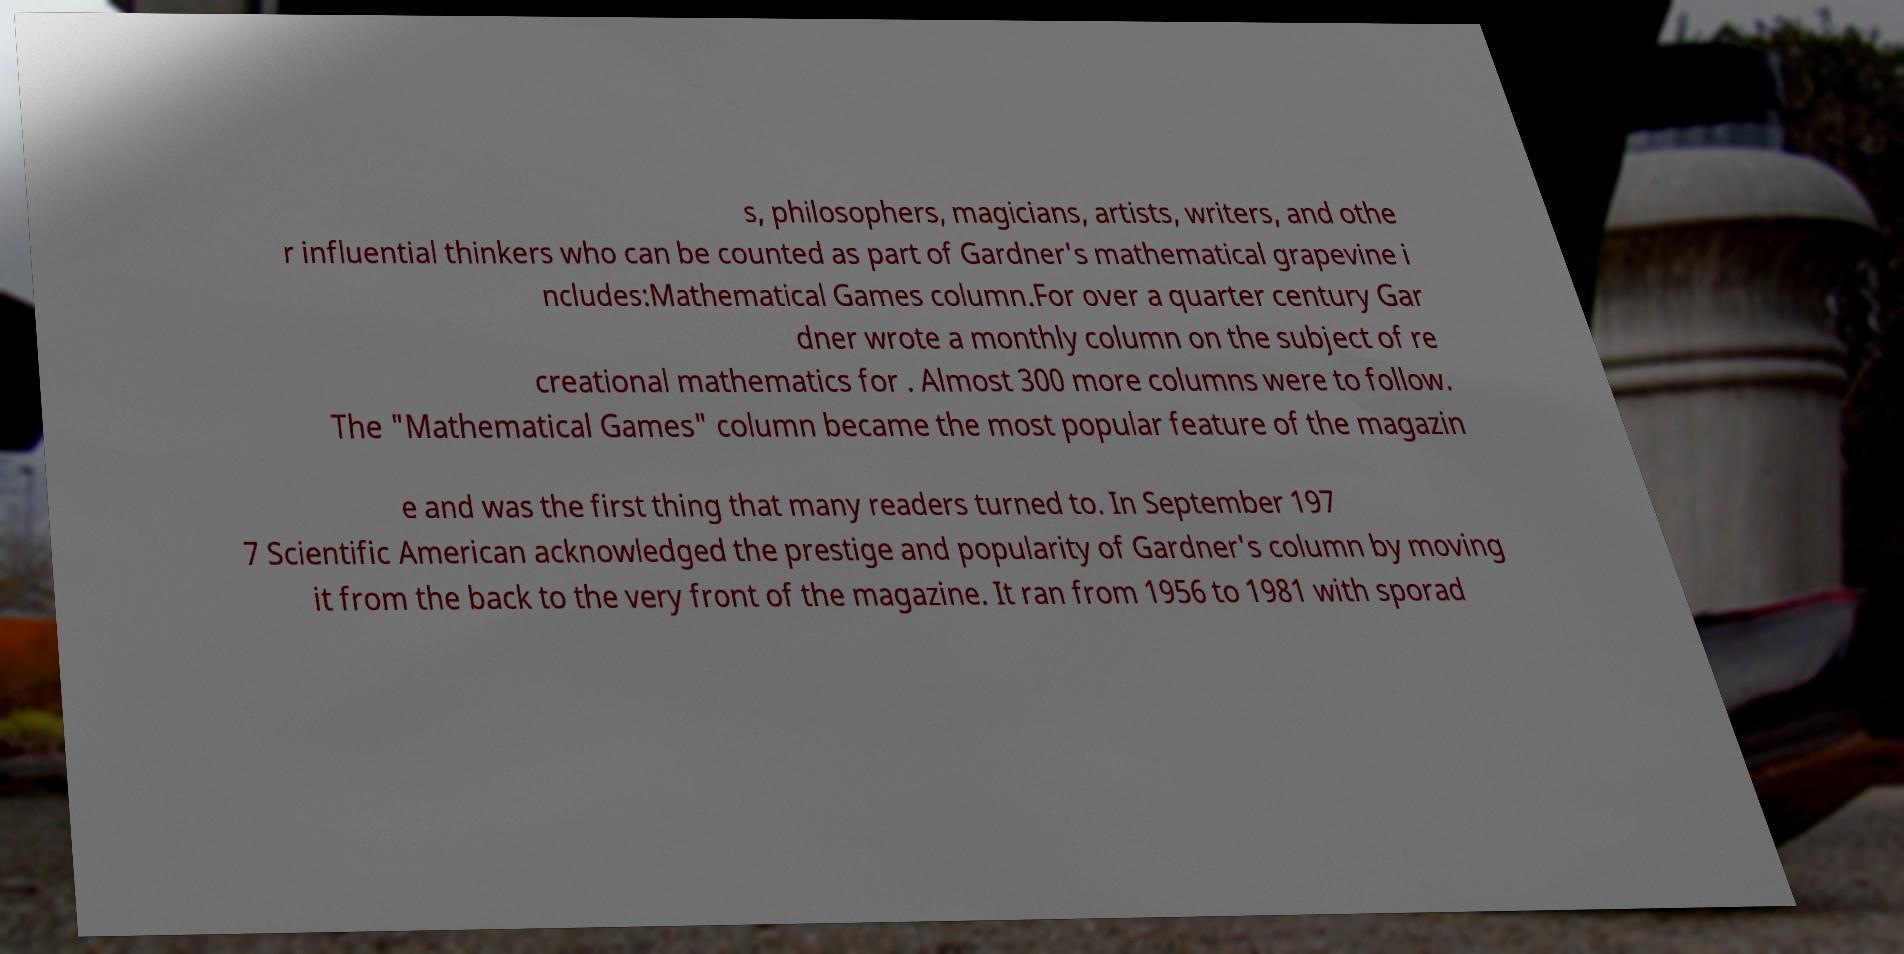Can you read and provide the text displayed in the image?This photo seems to have some interesting text. Can you extract and type it out for me? s, philosophers, magicians, artists, writers, and othe r influential thinkers who can be counted as part of Gardner's mathematical grapevine i ncludes:Mathematical Games column.For over a quarter century Gar dner wrote a monthly column on the subject of re creational mathematics for . Almost 300 more columns were to follow. The "Mathematical Games" column became the most popular feature of the magazin e and was the first thing that many readers turned to. In September 197 7 Scientific American acknowledged the prestige and popularity of Gardner's column by moving it from the back to the very front of the magazine. It ran from 1956 to 1981 with sporad 